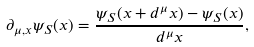Convert formula to latex. <formula><loc_0><loc_0><loc_500><loc_500>\partial _ { \mu , x } \psi _ { S } ( x ) = \frac { \psi _ { S } ( x + d ^ { \mu } x ) - \psi _ { S } ( x ) } { d ^ { \mu } x } ,</formula> 